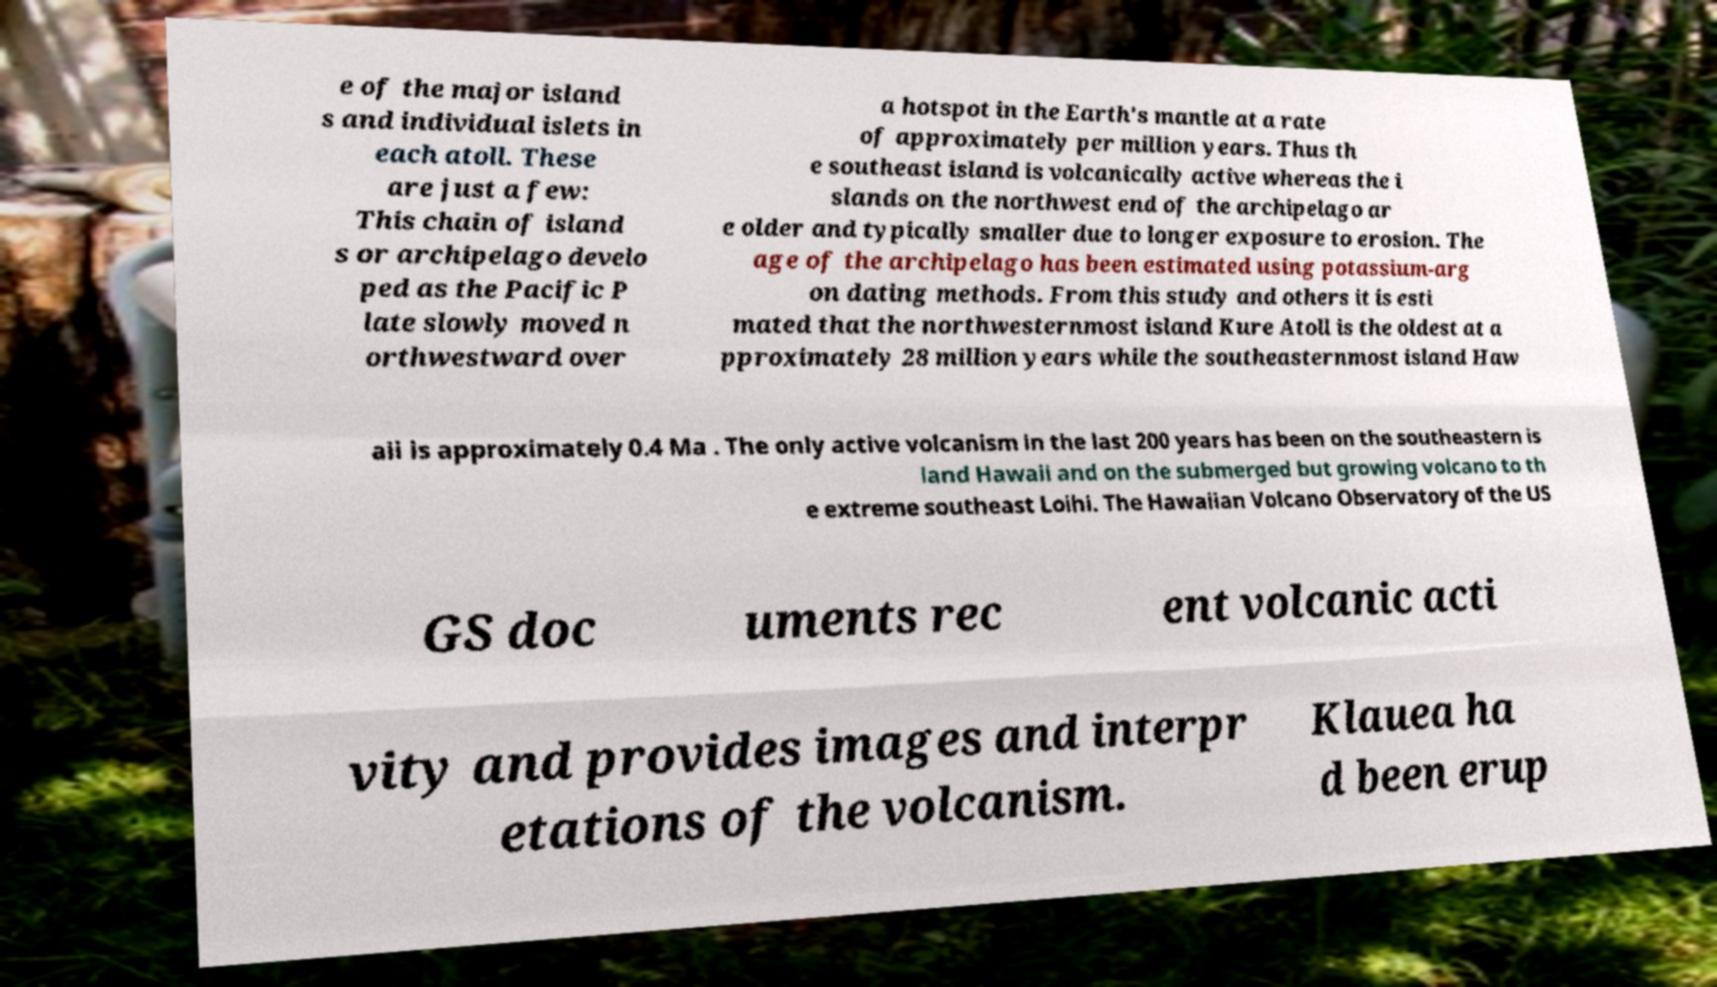Can you read and provide the text displayed in the image?This photo seems to have some interesting text. Can you extract and type it out for me? e of the major island s and individual islets in each atoll. These are just a few: This chain of island s or archipelago develo ped as the Pacific P late slowly moved n orthwestward over a hotspot in the Earth's mantle at a rate of approximately per million years. Thus th e southeast island is volcanically active whereas the i slands on the northwest end of the archipelago ar e older and typically smaller due to longer exposure to erosion. The age of the archipelago has been estimated using potassium-arg on dating methods. From this study and others it is esti mated that the northwesternmost island Kure Atoll is the oldest at a pproximately 28 million years while the southeasternmost island Haw aii is approximately 0.4 Ma . The only active volcanism in the last 200 years has been on the southeastern is land Hawaii and on the submerged but growing volcano to th e extreme southeast Loihi. The Hawaiian Volcano Observatory of the US GS doc uments rec ent volcanic acti vity and provides images and interpr etations of the volcanism. Klauea ha d been erup 